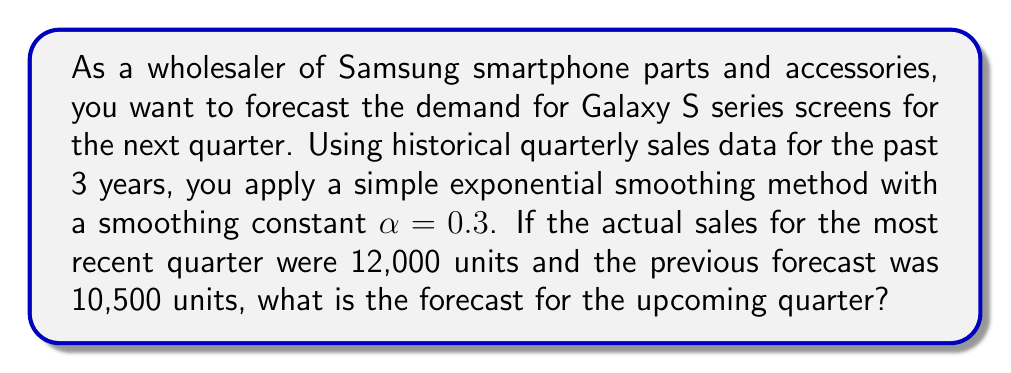Could you help me with this problem? To solve this problem, we'll use the simple exponential smoothing method, which is a time series forecasting technique. The formula for simple exponential smoothing is:

$$F_{t+1} = \alpha Y_t + (1-\alpha)F_t$$

Where:
$F_{t+1}$ is the forecast for the next period
$\alpha$ is the smoothing constant (0 < α < 1)
$Y_t$ is the actual value for the current period
$F_t$ is the forecast for the current period

Given:
- α = 0.3
- $Y_t$ (actual sales for most recent quarter) = 12,000 units
- $F_t$ (previous forecast) = 10,500 units

Let's substitute these values into the formula:

$$F_{t+1} = 0.3 \cdot 12,000 + (1-0.3) \cdot 10,500$$

Now, let's solve step-by-step:

1. Calculate the first term: 
   $0.3 \cdot 12,000 = 3,600$

2. Calculate $(1-\alpha)$:
   $1 - 0.3 = 0.7$

3. Calculate the second term:
   $0.7 \cdot 10,500 = 7,350$

4. Sum the two terms:
   $3,600 + 7,350 = 10,950$

Therefore, the forecast for the upcoming quarter is 10,950 units.
Answer: 10,950 units 